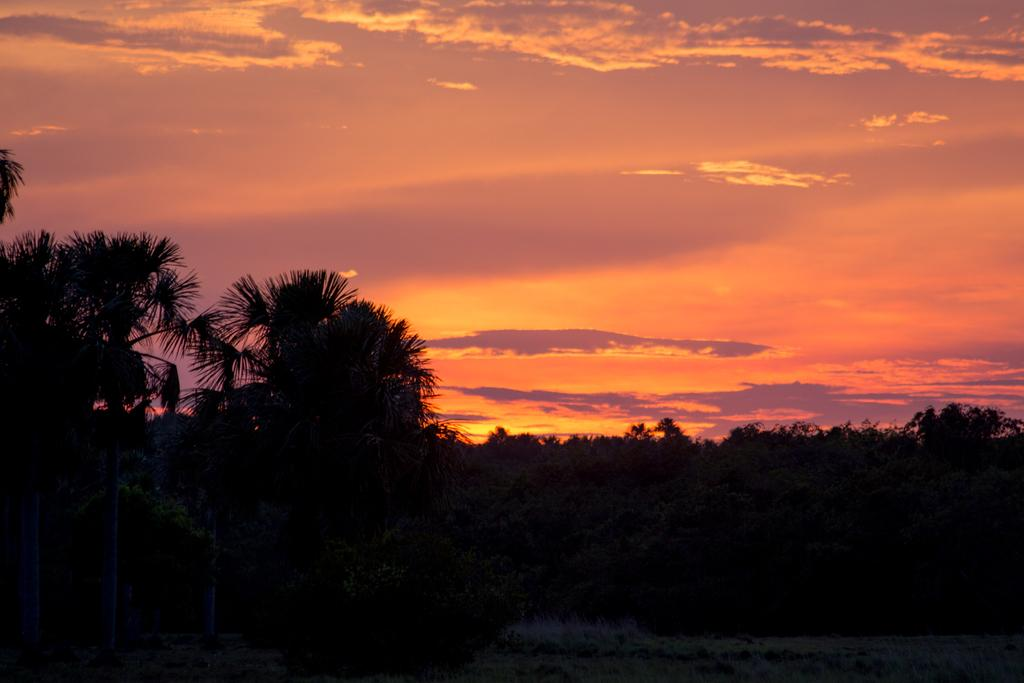What type of vegetation is present in the image? There are many trees and plants in the image. What can be seen above the vegetation in the image? The sky is visible in the image. What is present in the sky in the image? There are clouds in the sky. Where can the fairies be seen playing in the image? There are no fairies present in the image. What type of milk is being poured from the clouds in the image? There is no milk being poured from the clouds in the image; it is a natural scene with trees, plants, sky, and clouds. 